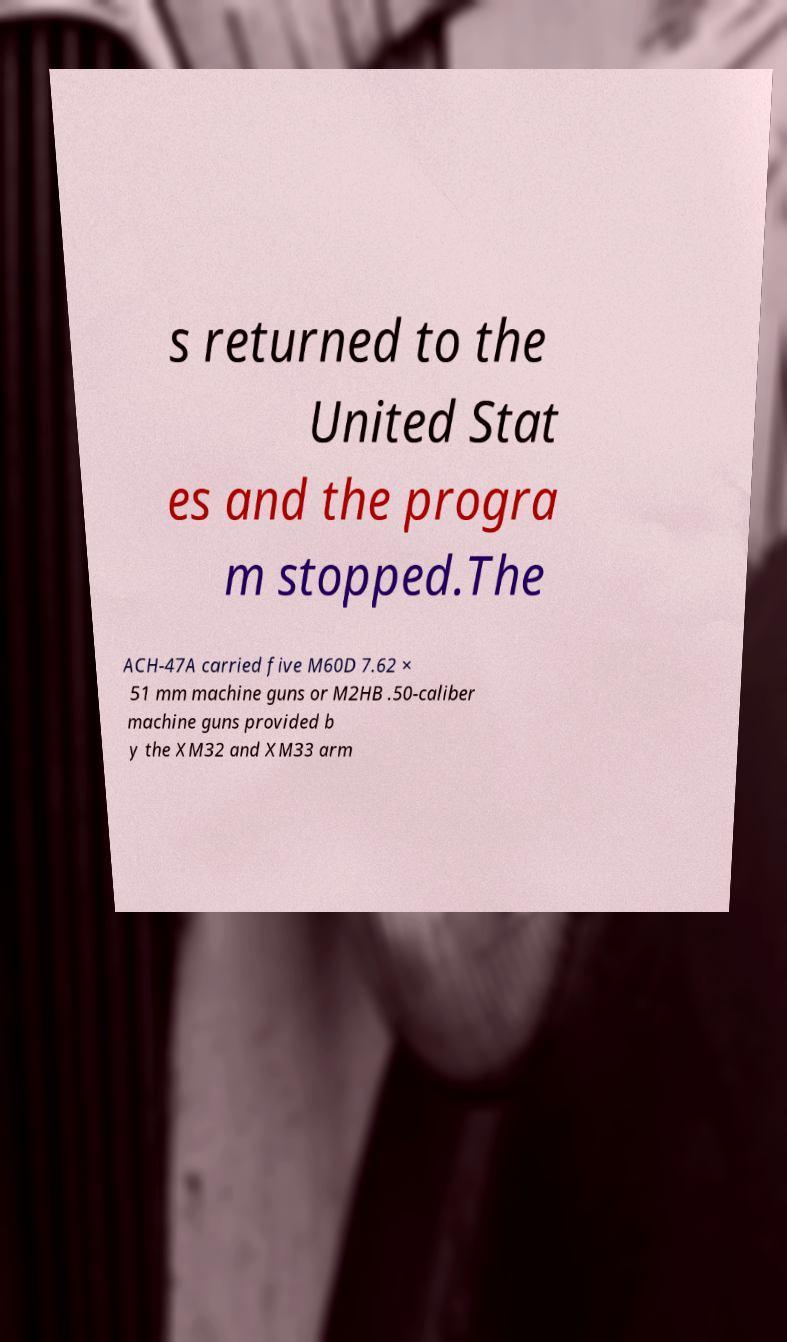There's text embedded in this image that I need extracted. Can you transcribe it verbatim? s returned to the United Stat es and the progra m stopped.The ACH-47A carried five M60D 7.62 × 51 mm machine guns or M2HB .50-caliber machine guns provided b y the XM32 and XM33 arm 